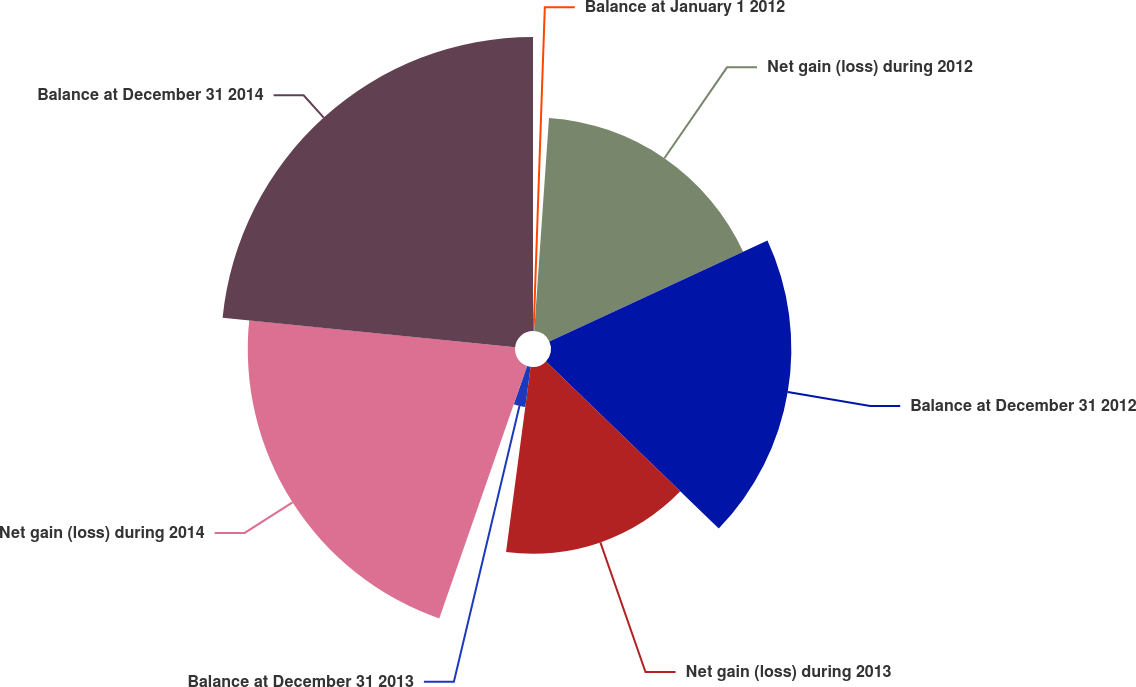<chart> <loc_0><loc_0><loc_500><loc_500><pie_chart><fcel>Balance at January 1 2012<fcel>Net gain (loss) during 2012<fcel>Balance at December 31 2012<fcel>Net gain (loss) during 2013<fcel>Balance at December 31 2013<fcel>Net gain (loss) during 2014<fcel>Balance at December 31 2014<nl><fcel>1.1%<fcel>17.0%<fcel>19.13%<fcel>14.87%<fcel>3.23%<fcel>21.27%<fcel>23.4%<nl></chart> 